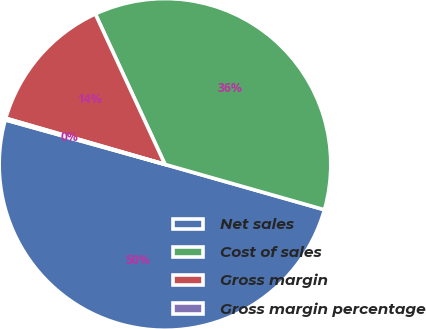Convert chart to OTSL. <chart><loc_0><loc_0><loc_500><loc_500><pie_chart><fcel>Net sales<fcel>Cost of sales<fcel>Gross margin<fcel>Gross margin percentage<nl><fcel>49.92%<fcel>36.31%<fcel>13.61%<fcel>0.16%<nl></chart> 